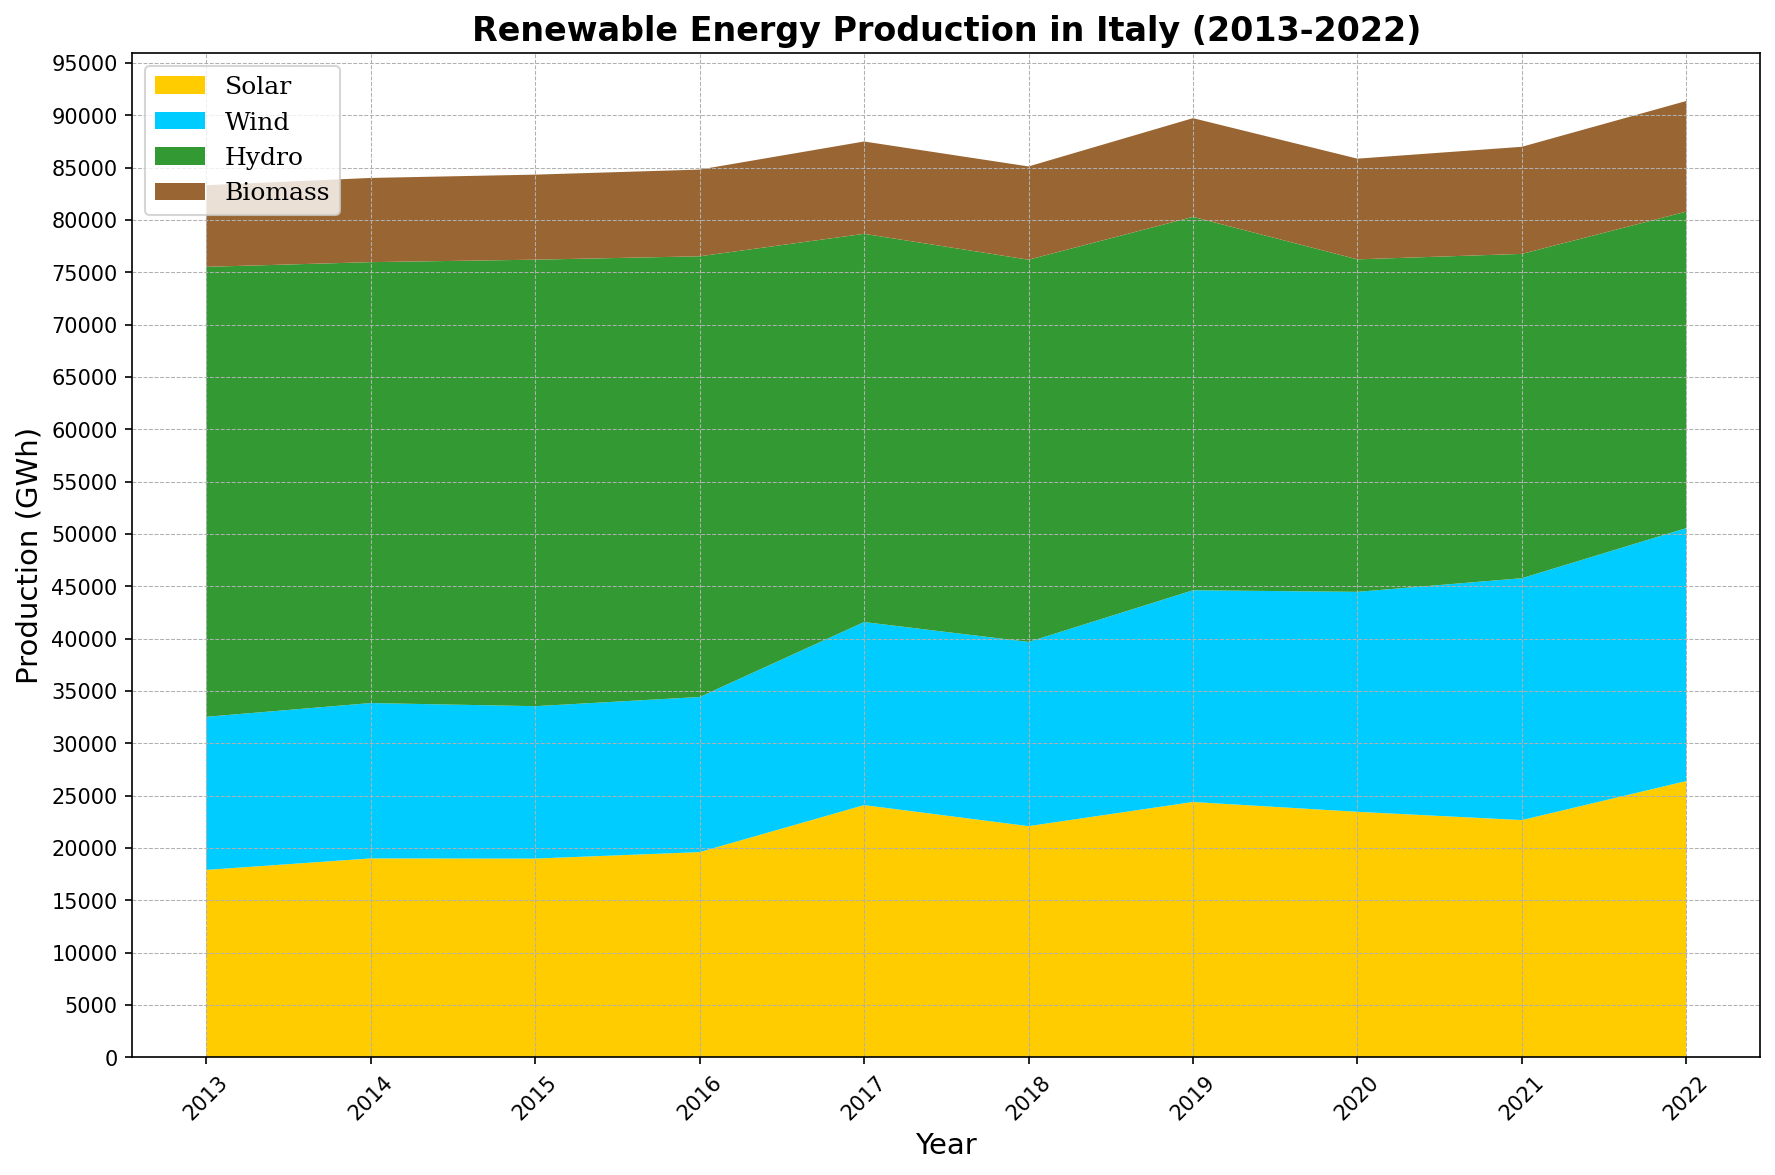What is the total renewable energy production in Italy in the year 2020? To find the total renewable energy production in the year 2020, sum up the production from all four sources: Solar (23460), Wind (21015), Hydro (31765), and Biomass (9620). This gives 23460 + 21015 + 31765 + 9620 = 85860 GWh.
Answer: 85860 GWh Which renewable energy source had the highest production in 2022? To find the highest production in 2022, compare the values for each source: Solar (26400), Wind (24165), Hydro (30238), and Biomass (10567). The highest value is for Hydro with 30238 GWh.
Answer: Hydro Between 2013 and 2022, in which year did Solar energy production peak? Observe the Solar energy production values for each year. The highest value is in 2022 with 26400 GWh.
Answer: 2022 How did the production of Wind energy change from 2017 to 2021? Note the Wind energy production values for 2017 (17490 GWh) and 2021 (23109 GWh). The change in production is 23109 - 17490 = 5619 GWh, indicating an increase.
Answer: Increased by 5619 GWh What is the overall trend in Hydro energy production from 2013 to 2022? Observe the Hydro energy production values for each year from 2013 to 2022. The trend shows a consistent decrease from 42988 GWh in 2013 to 30238 GWh in 2022.
Answer: Decreasing trend Which renewable energy source had the smallest production in 2016? Compare the production levels of each source in 2016: Solar (19610), Wind (14820), Hydro (42102), and Biomass (8284). Biomass had the smallest production with 8284 GWh.
Answer: Biomass On average, how much energy did Biomass produce per year from 2013 to 2022? Sum the Biomass production values for each year from 2013 to 2022 and divide by the number of years (10). (7798 + 8045 + 8126 + 8284 + 8821 + 8909 + 9429 + 9620 + 10232 + 10567) / 10 = 9073.1 GWh per year on average.
Answer: 9073.1 GWh 